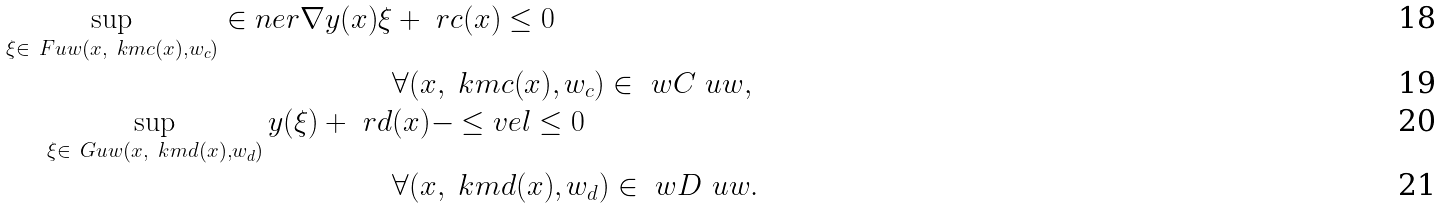Convert formula to latex. <formula><loc_0><loc_0><loc_500><loc_500>\sup _ { \xi \in \ F u w ( x , \ k m c ( x ) , w _ { c } ) } \in n e r { \nabla \L y ( x ) } { \xi } & + \ r c ( x ) \leq 0 \\ & \forall ( x , \ k m c ( x ) , w _ { c } ) \in \ w C \ u w , \\ \sup _ { \xi \in \ G u w ( x , \ k m d ( x ) , w _ { d } ) } \L y ( \xi ) + \ r d & ( x ) - \leq v e l \leq 0 \\ & \forall ( x , \ k m d ( x ) , w _ { d } ) \in \ w D \ u w .</formula> 